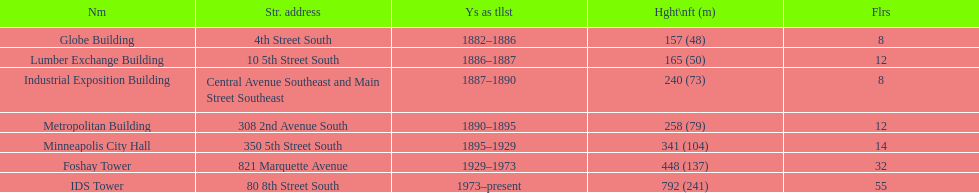Can you compare the heights of the metropolitan building and the lumber exchange building? Metropolitan Building. 